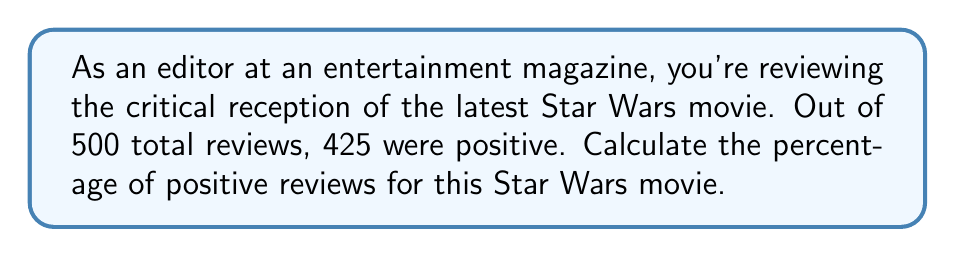Provide a solution to this math problem. To calculate the percentage of positive reviews, we need to follow these steps:

1. Identify the total number of reviews and the number of positive reviews:
   Total reviews: 500
   Positive reviews: 425

2. Set up the percentage formula:
   $$ \text{Percentage} = \frac{\text{Part}}{\text{Whole}} \times 100\% $$

3. Plug in the values:
   $$ \text{Percentage of positive reviews} = \frac{425}{500} \times 100\% $$

4. Perform the division:
   $$ \frac{425}{500} = 0.85 $$

5. Multiply by 100% to get the final percentage:
   $$ 0.85 \times 100\% = 85\% $$

Therefore, the percentage of positive reviews for the Star Wars movie is 85%.
Answer: 85% 